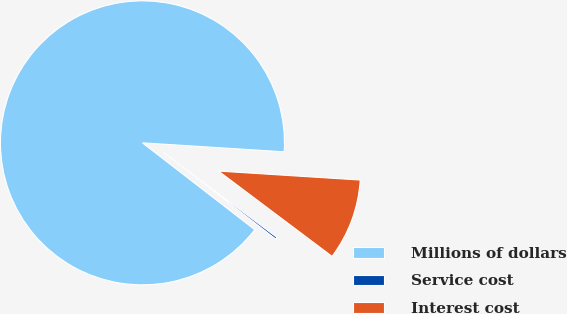Convert chart. <chart><loc_0><loc_0><loc_500><loc_500><pie_chart><fcel>Millions of dollars<fcel>Service cost<fcel>Interest cost<nl><fcel>90.52%<fcel>0.22%<fcel>9.25%<nl></chart> 